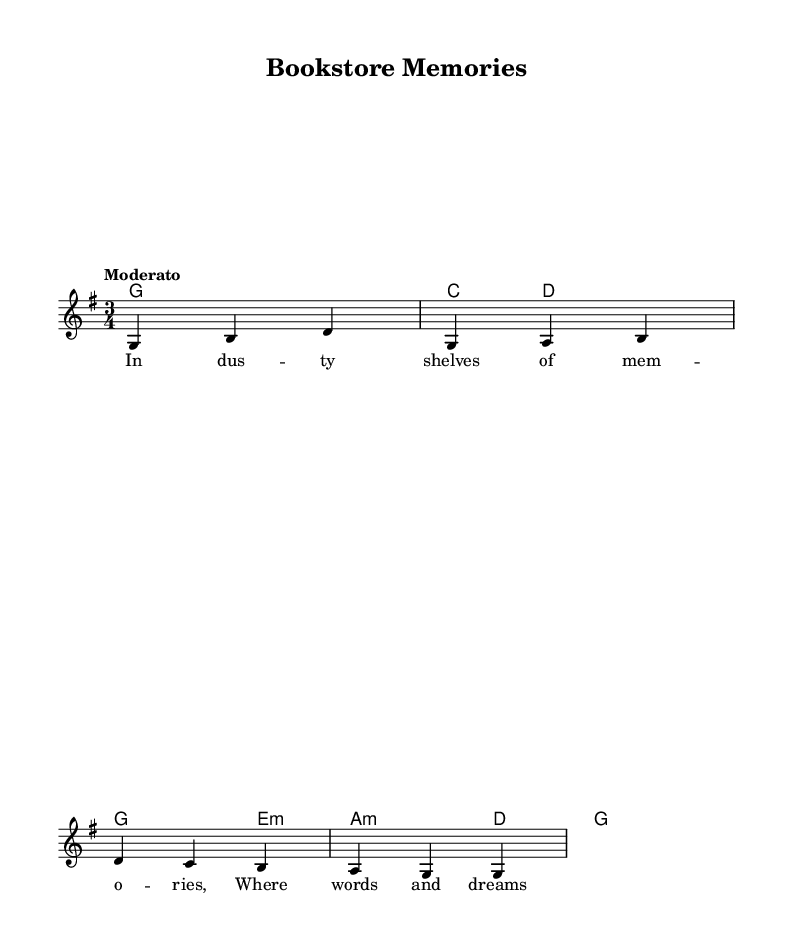What is the key signature of this music? The key signature shows one sharp, indicating it is in the key of G major.
Answer: G major What is the time signature of this piece? The time signature is indicated as 3/4, meaning there are three beats in each measure.
Answer: 3/4 What is the tempo marking for this music? The tempo marking is "Moderato", which describes a moderate pace for the piece.
Answer: Moderato How many measures are in the score? Counting the measures, there are a total of four measures presented in the music sheet.
Answer: Four What is the first word of the lyrics? The first word of the lyrics is "In", as seen in the line of the lyrics indicated under the melody.
Answer: In What chord is played in the second measure? The chord in the second measure is C major, as indicated in the chord progression.
Answer: C major What style of music does this piece represent? The piece represents Folk music, as the lyrics are adapted from poetry and the musical structure is typical of traditional folk tunes.
Answer: Folk 